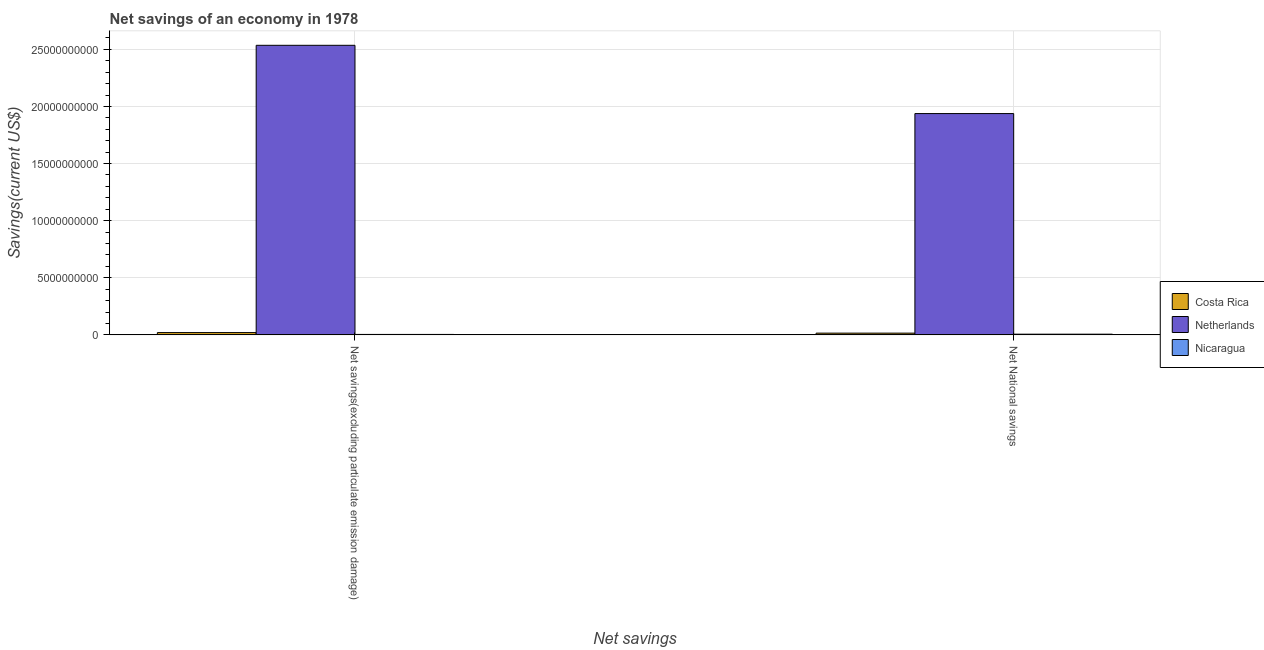How many bars are there on the 1st tick from the left?
Your answer should be compact. 3. How many bars are there on the 2nd tick from the right?
Offer a terse response. 3. What is the label of the 1st group of bars from the left?
Keep it short and to the point. Net savings(excluding particulate emission damage). What is the net national savings in Nicaragua?
Keep it short and to the point. 6.22e+07. Across all countries, what is the maximum net savings(excluding particulate emission damage)?
Offer a terse response. 2.54e+1. Across all countries, what is the minimum net national savings?
Your answer should be compact. 6.22e+07. In which country was the net national savings minimum?
Provide a short and direct response. Nicaragua. What is the total net savings(excluding particulate emission damage) in the graph?
Your answer should be very brief. 2.56e+1. What is the difference between the net national savings in Nicaragua and that in Costa Rica?
Your answer should be very brief. -9.14e+07. What is the difference between the net savings(excluding particulate emission damage) in Nicaragua and the net national savings in Netherlands?
Give a very brief answer. -1.93e+1. What is the average net savings(excluding particulate emission damage) per country?
Your response must be concise. 8.53e+09. What is the difference between the net national savings and net savings(excluding particulate emission damage) in Nicaragua?
Your answer should be compact. 2.25e+07. In how many countries, is the net savings(excluding particulate emission damage) greater than 4000000000 US$?
Give a very brief answer. 1. What is the ratio of the net national savings in Nicaragua to that in Netherlands?
Your answer should be very brief. 0. In how many countries, is the net national savings greater than the average net national savings taken over all countries?
Offer a terse response. 1. What does the 1st bar from the right in Net National savings represents?
Offer a terse response. Nicaragua. Are all the bars in the graph horizontal?
Make the answer very short. No. How many countries are there in the graph?
Your response must be concise. 3. Does the graph contain any zero values?
Give a very brief answer. No. Does the graph contain grids?
Your response must be concise. Yes. Where does the legend appear in the graph?
Give a very brief answer. Center right. What is the title of the graph?
Offer a very short reply. Net savings of an economy in 1978. Does "Thailand" appear as one of the legend labels in the graph?
Make the answer very short. No. What is the label or title of the X-axis?
Offer a very short reply. Net savings. What is the label or title of the Y-axis?
Offer a terse response. Savings(current US$). What is the Savings(current US$) in Costa Rica in Net savings(excluding particulate emission damage)?
Your answer should be very brief. 2.01e+08. What is the Savings(current US$) of Netherlands in Net savings(excluding particulate emission damage)?
Your response must be concise. 2.54e+1. What is the Savings(current US$) in Nicaragua in Net savings(excluding particulate emission damage)?
Your answer should be compact. 3.96e+07. What is the Savings(current US$) of Costa Rica in Net National savings?
Give a very brief answer. 1.54e+08. What is the Savings(current US$) in Netherlands in Net National savings?
Offer a very short reply. 1.94e+1. What is the Savings(current US$) in Nicaragua in Net National savings?
Provide a succinct answer. 6.22e+07. Across all Net savings, what is the maximum Savings(current US$) of Costa Rica?
Ensure brevity in your answer.  2.01e+08. Across all Net savings, what is the maximum Savings(current US$) in Netherlands?
Your response must be concise. 2.54e+1. Across all Net savings, what is the maximum Savings(current US$) of Nicaragua?
Make the answer very short. 6.22e+07. Across all Net savings, what is the minimum Savings(current US$) of Costa Rica?
Provide a short and direct response. 1.54e+08. Across all Net savings, what is the minimum Savings(current US$) in Netherlands?
Offer a very short reply. 1.94e+1. Across all Net savings, what is the minimum Savings(current US$) in Nicaragua?
Your response must be concise. 3.96e+07. What is the total Savings(current US$) of Costa Rica in the graph?
Give a very brief answer. 3.55e+08. What is the total Savings(current US$) in Netherlands in the graph?
Offer a terse response. 4.47e+1. What is the total Savings(current US$) in Nicaragua in the graph?
Make the answer very short. 1.02e+08. What is the difference between the Savings(current US$) of Costa Rica in Net savings(excluding particulate emission damage) and that in Net National savings?
Offer a terse response. 4.76e+07. What is the difference between the Savings(current US$) of Netherlands in Net savings(excluding particulate emission damage) and that in Net National savings?
Ensure brevity in your answer.  5.98e+09. What is the difference between the Savings(current US$) in Nicaragua in Net savings(excluding particulate emission damage) and that in Net National savings?
Your answer should be very brief. -2.25e+07. What is the difference between the Savings(current US$) of Costa Rica in Net savings(excluding particulate emission damage) and the Savings(current US$) of Netherlands in Net National savings?
Provide a short and direct response. -1.92e+1. What is the difference between the Savings(current US$) of Costa Rica in Net savings(excluding particulate emission damage) and the Savings(current US$) of Nicaragua in Net National savings?
Ensure brevity in your answer.  1.39e+08. What is the difference between the Savings(current US$) of Netherlands in Net savings(excluding particulate emission damage) and the Savings(current US$) of Nicaragua in Net National savings?
Your answer should be very brief. 2.53e+1. What is the average Savings(current US$) in Costa Rica per Net savings?
Provide a short and direct response. 1.77e+08. What is the average Savings(current US$) in Netherlands per Net savings?
Provide a short and direct response. 2.24e+1. What is the average Savings(current US$) in Nicaragua per Net savings?
Your answer should be very brief. 5.09e+07. What is the difference between the Savings(current US$) in Costa Rica and Savings(current US$) in Netherlands in Net savings(excluding particulate emission damage)?
Offer a very short reply. -2.51e+1. What is the difference between the Savings(current US$) in Costa Rica and Savings(current US$) in Nicaragua in Net savings(excluding particulate emission damage)?
Provide a short and direct response. 1.62e+08. What is the difference between the Savings(current US$) of Netherlands and Savings(current US$) of Nicaragua in Net savings(excluding particulate emission damage)?
Offer a very short reply. 2.53e+1. What is the difference between the Savings(current US$) in Costa Rica and Savings(current US$) in Netherlands in Net National savings?
Offer a very short reply. -1.92e+1. What is the difference between the Savings(current US$) in Costa Rica and Savings(current US$) in Nicaragua in Net National savings?
Your response must be concise. 9.14e+07. What is the difference between the Savings(current US$) in Netherlands and Savings(current US$) in Nicaragua in Net National savings?
Provide a succinct answer. 1.93e+1. What is the ratio of the Savings(current US$) in Costa Rica in Net savings(excluding particulate emission damage) to that in Net National savings?
Provide a short and direct response. 1.31. What is the ratio of the Savings(current US$) in Netherlands in Net savings(excluding particulate emission damage) to that in Net National savings?
Your answer should be very brief. 1.31. What is the ratio of the Savings(current US$) of Nicaragua in Net savings(excluding particulate emission damage) to that in Net National savings?
Keep it short and to the point. 0.64. What is the difference between the highest and the second highest Savings(current US$) of Costa Rica?
Your answer should be compact. 4.76e+07. What is the difference between the highest and the second highest Savings(current US$) of Netherlands?
Offer a terse response. 5.98e+09. What is the difference between the highest and the second highest Savings(current US$) in Nicaragua?
Offer a terse response. 2.25e+07. What is the difference between the highest and the lowest Savings(current US$) in Costa Rica?
Your answer should be compact. 4.76e+07. What is the difference between the highest and the lowest Savings(current US$) in Netherlands?
Give a very brief answer. 5.98e+09. What is the difference between the highest and the lowest Savings(current US$) in Nicaragua?
Your answer should be compact. 2.25e+07. 